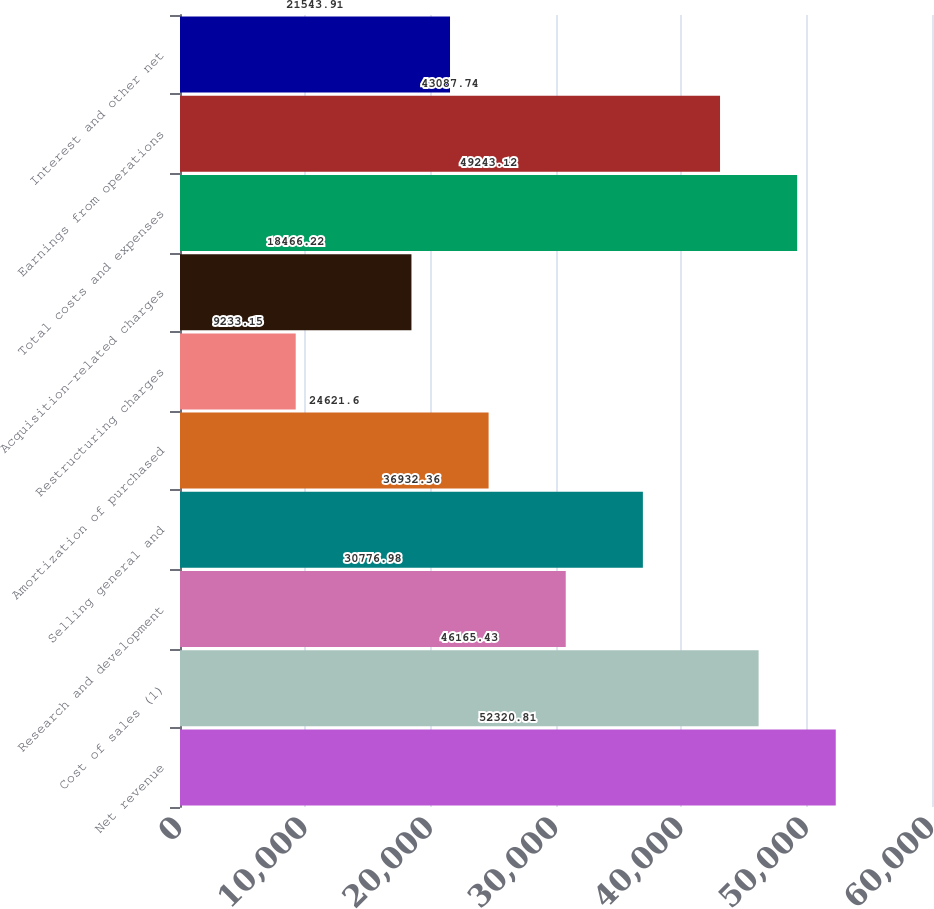Convert chart. <chart><loc_0><loc_0><loc_500><loc_500><bar_chart><fcel>Net revenue<fcel>Cost of sales (1)<fcel>Research and development<fcel>Selling general and<fcel>Amortization of purchased<fcel>Restructuring charges<fcel>Acquisition-related charges<fcel>Total costs and expenses<fcel>Earnings from operations<fcel>Interest and other net<nl><fcel>52320.8<fcel>46165.4<fcel>30777<fcel>36932.4<fcel>24621.6<fcel>9233.15<fcel>18466.2<fcel>49243.1<fcel>43087.7<fcel>21543.9<nl></chart> 